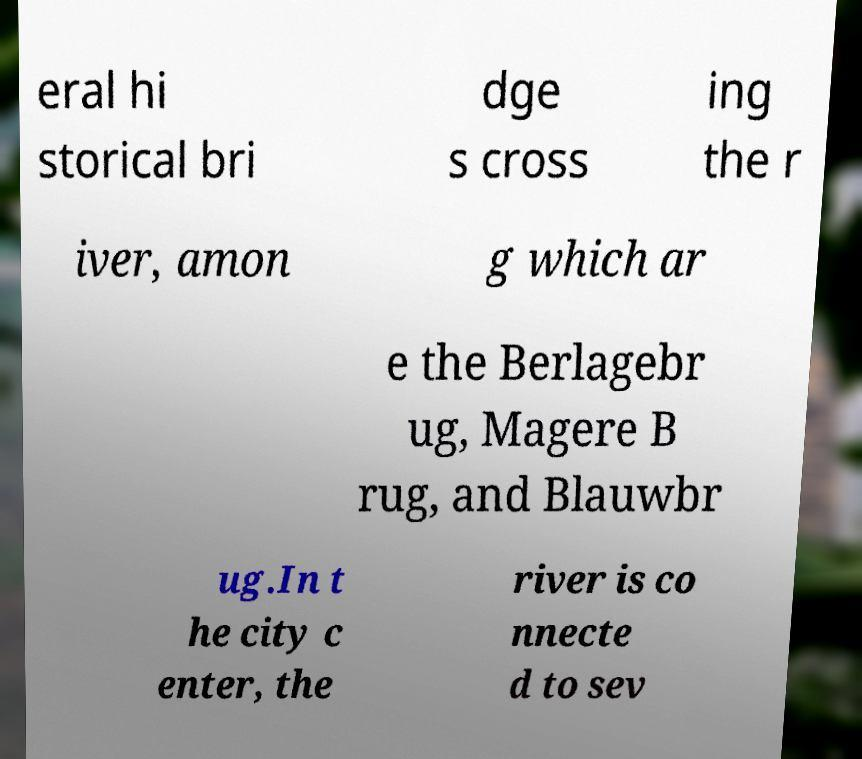There's text embedded in this image that I need extracted. Can you transcribe it verbatim? eral hi storical bri dge s cross ing the r iver, amon g which ar e the Berlagebr ug, Magere B rug, and Blauwbr ug.In t he city c enter, the river is co nnecte d to sev 